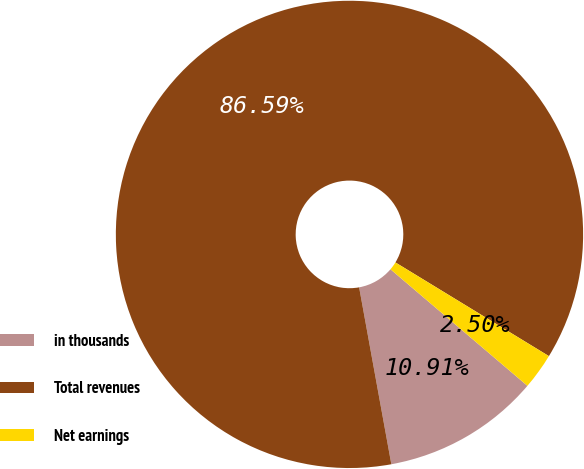Convert chart to OTSL. <chart><loc_0><loc_0><loc_500><loc_500><pie_chart><fcel>in thousands<fcel>Total revenues<fcel>Net earnings<nl><fcel>10.91%<fcel>86.58%<fcel>2.5%<nl></chart> 